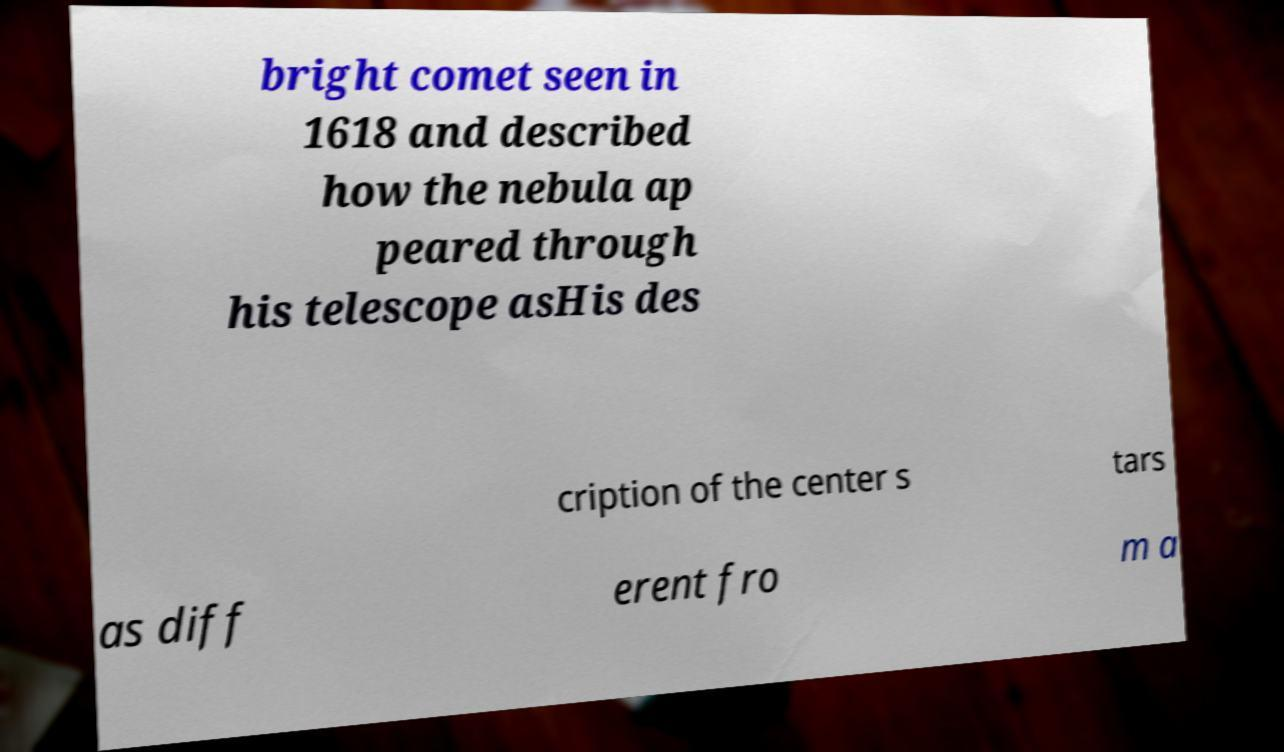Can you accurately transcribe the text from the provided image for me? bright comet seen in 1618 and described how the nebula ap peared through his telescope asHis des cription of the center s tars as diff erent fro m a 